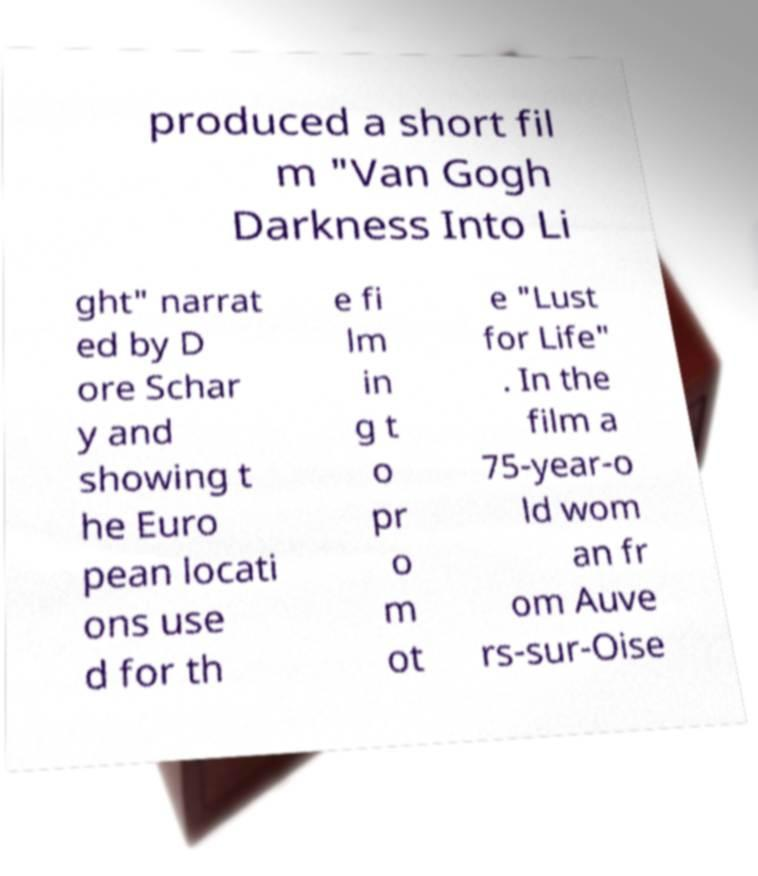Can you read and provide the text displayed in the image?This photo seems to have some interesting text. Can you extract and type it out for me? produced a short fil m "Van Gogh Darkness Into Li ght" narrat ed by D ore Schar y and showing t he Euro pean locati ons use d for th e fi lm in g t o pr o m ot e "Lust for Life" . In the film a 75-year-o ld wom an fr om Auve rs-sur-Oise 